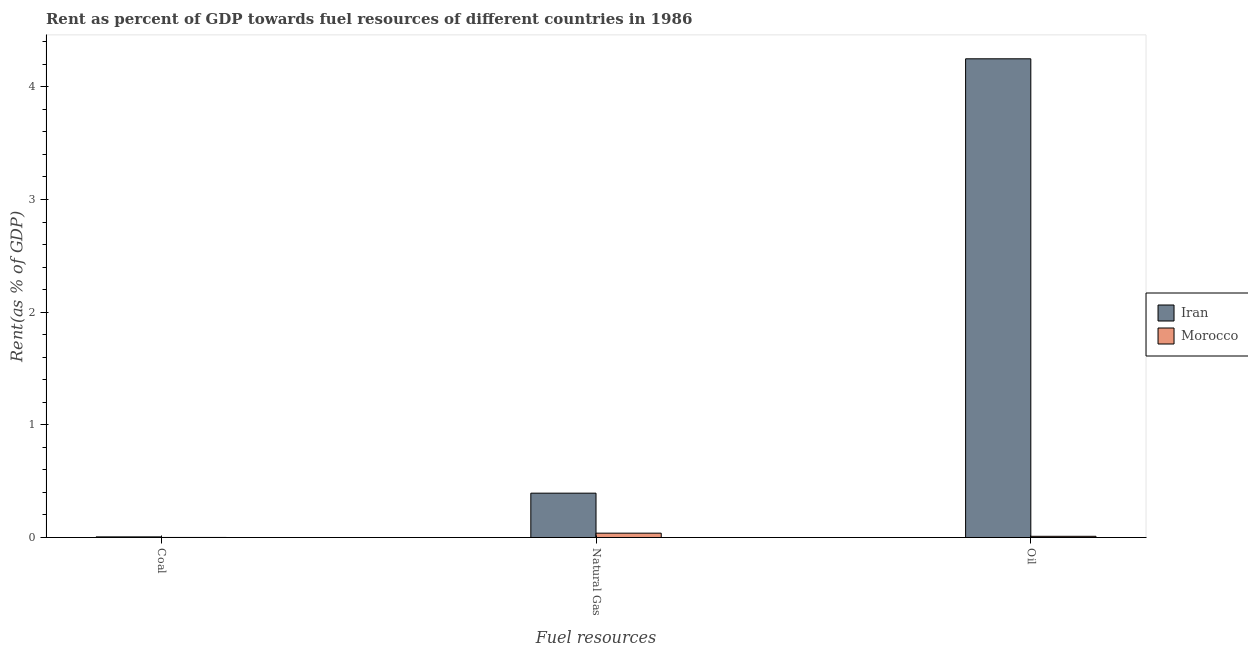How many groups of bars are there?
Offer a very short reply. 3. Are the number of bars on each tick of the X-axis equal?
Make the answer very short. Yes. How many bars are there on the 1st tick from the left?
Ensure brevity in your answer.  2. What is the label of the 2nd group of bars from the left?
Give a very brief answer. Natural Gas. What is the rent towards natural gas in Iran?
Offer a terse response. 0.39. Across all countries, what is the maximum rent towards coal?
Offer a very short reply. 0.01. Across all countries, what is the minimum rent towards natural gas?
Offer a very short reply. 0.04. In which country was the rent towards oil maximum?
Keep it short and to the point. Iran. In which country was the rent towards coal minimum?
Keep it short and to the point. Morocco. What is the total rent towards natural gas in the graph?
Ensure brevity in your answer.  0.43. What is the difference between the rent towards natural gas in Iran and that in Morocco?
Provide a succinct answer. 0.35. What is the difference between the rent towards natural gas in Morocco and the rent towards coal in Iran?
Ensure brevity in your answer.  0.03. What is the average rent towards coal per country?
Offer a terse response. 0. What is the difference between the rent towards natural gas and rent towards oil in Morocco?
Provide a succinct answer. 0.03. What is the ratio of the rent towards coal in Morocco to that in Iran?
Provide a succinct answer. 0.05. What is the difference between the highest and the second highest rent towards oil?
Your response must be concise. 4.24. What is the difference between the highest and the lowest rent towards natural gas?
Provide a succinct answer. 0.35. Is the sum of the rent towards coal in Iran and Morocco greater than the maximum rent towards natural gas across all countries?
Offer a very short reply. No. What does the 1st bar from the left in Coal represents?
Your response must be concise. Iran. What does the 2nd bar from the right in Natural Gas represents?
Keep it short and to the point. Iran. Is it the case that in every country, the sum of the rent towards coal and rent towards natural gas is greater than the rent towards oil?
Provide a short and direct response. No. Are all the bars in the graph horizontal?
Your response must be concise. No. Are the values on the major ticks of Y-axis written in scientific E-notation?
Keep it short and to the point. No. Does the graph contain any zero values?
Your response must be concise. No. Does the graph contain grids?
Your answer should be compact. No. How are the legend labels stacked?
Offer a very short reply. Vertical. What is the title of the graph?
Ensure brevity in your answer.  Rent as percent of GDP towards fuel resources of different countries in 1986. Does "Low & middle income" appear as one of the legend labels in the graph?
Provide a short and direct response. No. What is the label or title of the X-axis?
Give a very brief answer. Fuel resources. What is the label or title of the Y-axis?
Offer a terse response. Rent(as % of GDP). What is the Rent(as % of GDP) of Iran in Coal?
Ensure brevity in your answer.  0.01. What is the Rent(as % of GDP) of Morocco in Coal?
Provide a succinct answer. 0. What is the Rent(as % of GDP) in Iran in Natural Gas?
Make the answer very short. 0.39. What is the Rent(as % of GDP) in Morocco in Natural Gas?
Provide a short and direct response. 0.04. What is the Rent(as % of GDP) in Iran in Oil?
Offer a very short reply. 4.25. What is the Rent(as % of GDP) of Morocco in Oil?
Offer a terse response. 0.01. Across all Fuel resources, what is the maximum Rent(as % of GDP) of Iran?
Provide a short and direct response. 4.25. Across all Fuel resources, what is the maximum Rent(as % of GDP) of Morocco?
Your answer should be very brief. 0.04. Across all Fuel resources, what is the minimum Rent(as % of GDP) in Iran?
Offer a very short reply. 0.01. Across all Fuel resources, what is the minimum Rent(as % of GDP) of Morocco?
Give a very brief answer. 0. What is the total Rent(as % of GDP) in Iran in the graph?
Your answer should be compact. 4.65. What is the total Rent(as % of GDP) in Morocco in the graph?
Ensure brevity in your answer.  0.05. What is the difference between the Rent(as % of GDP) of Iran in Coal and that in Natural Gas?
Give a very brief answer. -0.39. What is the difference between the Rent(as % of GDP) of Morocco in Coal and that in Natural Gas?
Give a very brief answer. -0.04. What is the difference between the Rent(as % of GDP) of Iran in Coal and that in Oil?
Offer a terse response. -4.24. What is the difference between the Rent(as % of GDP) of Morocco in Coal and that in Oil?
Provide a succinct answer. -0.01. What is the difference between the Rent(as % of GDP) of Iran in Natural Gas and that in Oil?
Ensure brevity in your answer.  -3.86. What is the difference between the Rent(as % of GDP) in Morocco in Natural Gas and that in Oil?
Offer a terse response. 0.03. What is the difference between the Rent(as % of GDP) in Iran in Coal and the Rent(as % of GDP) in Morocco in Natural Gas?
Provide a short and direct response. -0.03. What is the difference between the Rent(as % of GDP) of Iran in Coal and the Rent(as % of GDP) of Morocco in Oil?
Your answer should be very brief. -0.01. What is the difference between the Rent(as % of GDP) of Iran in Natural Gas and the Rent(as % of GDP) of Morocco in Oil?
Ensure brevity in your answer.  0.38. What is the average Rent(as % of GDP) of Iran per Fuel resources?
Provide a short and direct response. 1.55. What is the average Rent(as % of GDP) in Morocco per Fuel resources?
Provide a succinct answer. 0.02. What is the difference between the Rent(as % of GDP) of Iran and Rent(as % of GDP) of Morocco in Coal?
Offer a very short reply. 0.01. What is the difference between the Rent(as % of GDP) in Iran and Rent(as % of GDP) in Morocco in Natural Gas?
Make the answer very short. 0.35. What is the difference between the Rent(as % of GDP) in Iran and Rent(as % of GDP) in Morocco in Oil?
Ensure brevity in your answer.  4.24. What is the ratio of the Rent(as % of GDP) in Iran in Coal to that in Natural Gas?
Give a very brief answer. 0.01. What is the ratio of the Rent(as % of GDP) in Morocco in Coal to that in Natural Gas?
Make the answer very short. 0.01. What is the ratio of the Rent(as % of GDP) of Iran in Coal to that in Oil?
Your answer should be very brief. 0. What is the ratio of the Rent(as % of GDP) in Morocco in Coal to that in Oil?
Provide a succinct answer. 0.03. What is the ratio of the Rent(as % of GDP) in Iran in Natural Gas to that in Oil?
Ensure brevity in your answer.  0.09. What is the ratio of the Rent(as % of GDP) in Morocco in Natural Gas to that in Oil?
Make the answer very short. 3.65. What is the difference between the highest and the second highest Rent(as % of GDP) of Iran?
Give a very brief answer. 3.86. What is the difference between the highest and the second highest Rent(as % of GDP) of Morocco?
Make the answer very short. 0.03. What is the difference between the highest and the lowest Rent(as % of GDP) in Iran?
Keep it short and to the point. 4.24. What is the difference between the highest and the lowest Rent(as % of GDP) of Morocco?
Ensure brevity in your answer.  0.04. 